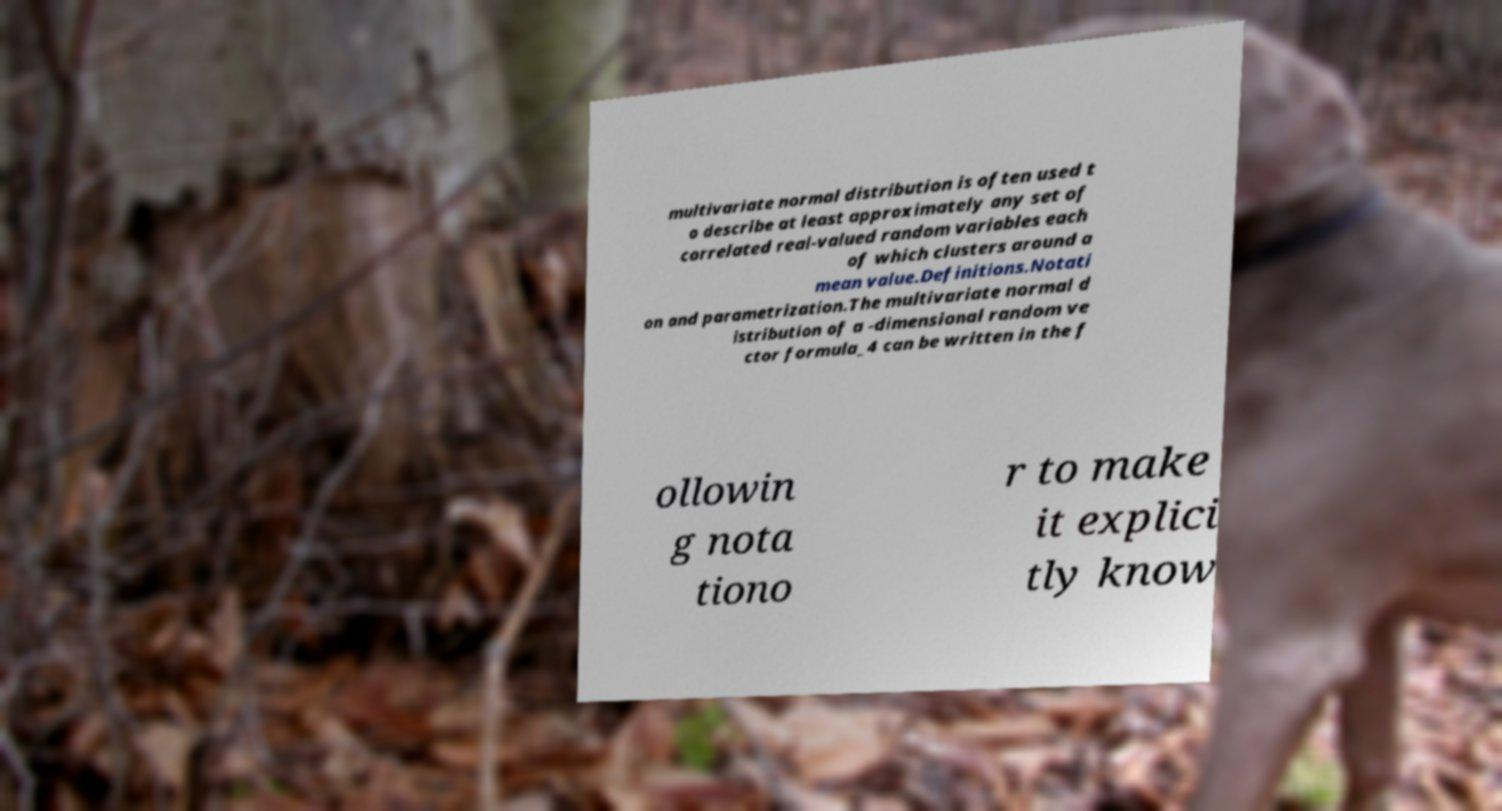Can you read and provide the text displayed in the image?This photo seems to have some interesting text. Can you extract and type it out for me? multivariate normal distribution is often used t o describe at least approximately any set of correlated real-valued random variables each of which clusters around a mean value.Definitions.Notati on and parametrization.The multivariate normal d istribution of a -dimensional random ve ctor formula_4 can be written in the f ollowin g nota tiono r to make it explici tly know 